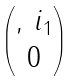<formula> <loc_0><loc_0><loc_500><loc_500>\begin{pmatrix} , \, i _ { 1 } \\ 0 \end{pmatrix}</formula> 